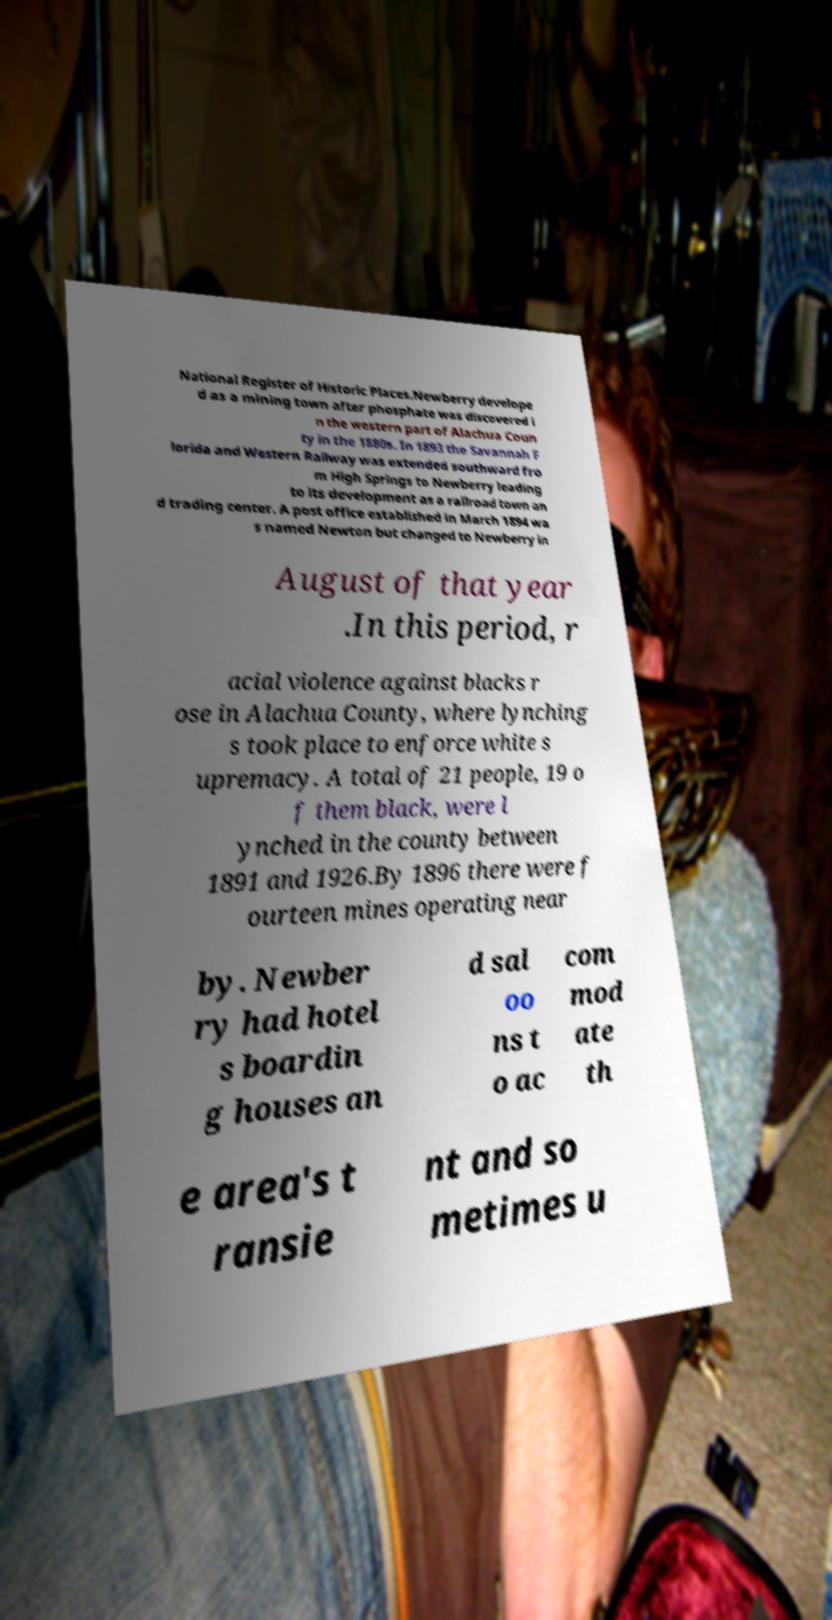What messages or text are displayed in this image? I need them in a readable, typed format. National Register of Historic Places.Newberry develope d as a mining town after phosphate was discovered i n the western part of Alachua Coun ty in the 1880s. In 1893 the Savannah F lorida and Western Railway was extended southward fro m High Springs to Newberry leading to its development as a railroad town an d trading center. A post office established in March 1894 wa s named Newton but changed to Newberry in August of that year .In this period, r acial violence against blacks r ose in Alachua County, where lynching s took place to enforce white s upremacy. A total of 21 people, 19 o f them black, were l ynched in the county between 1891 and 1926.By 1896 there were f ourteen mines operating near by. Newber ry had hotel s boardin g houses an d sal oo ns t o ac com mod ate th e area's t ransie nt and so metimes u 